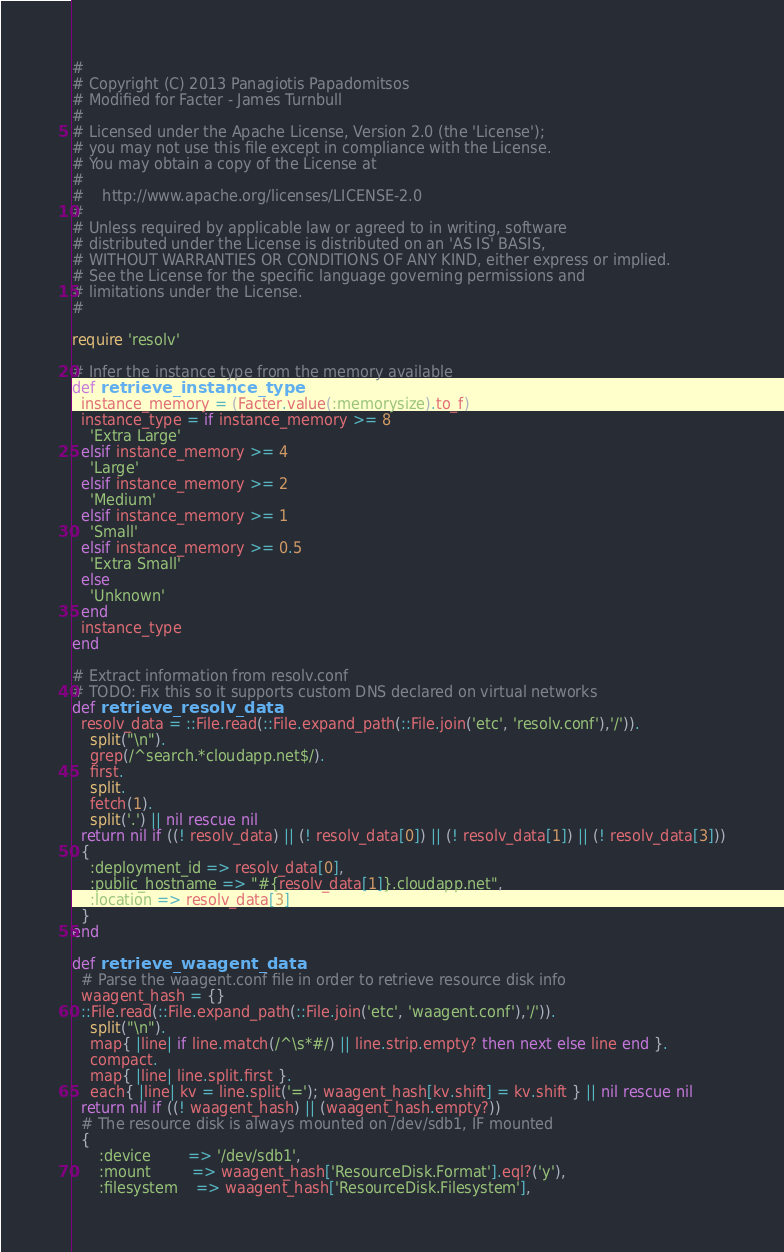<code> <loc_0><loc_0><loc_500><loc_500><_Ruby_>#
# Copyright (C) 2013 Panagiotis Papadomitsos
# Modified for Facter - James Turnbull
#
# Licensed under the Apache License, Version 2.0 (the 'License');
# you may not use this file except in compliance with the License.
# You may obtain a copy of the License at
#
#    http://www.apache.org/licenses/LICENSE-2.0
#
# Unless required by applicable law or agreed to in writing, software
# distributed under the License is distributed on an 'AS IS' BASIS,
# WITHOUT WARRANTIES OR CONDITIONS OF ANY KIND, either express or implied.
# See the License for the specific language governing permissions and
# limitations under the License.
#

require 'resolv'

# Infer the instance type from the memory available
def retrieve_instance_type
  instance_memory = (Facter.value(:memorysize).to_f)
  instance_type = if instance_memory >= 8
    'Extra Large'
  elsif instance_memory >= 4
    'Large'
  elsif instance_memory >= 2
    'Medium'
  elsif instance_memory >= 1
    'Small'
  elsif instance_memory >= 0.5
    'Extra Small'
  else
    'Unknown'
  end
  instance_type
end

# Extract information from resolv.conf
# TODO: Fix this so it supports custom DNS declared on virtual networks
def retrieve_resolv_data
  resolv_data = ::File.read(::File.expand_path(::File.join('etc', 'resolv.conf'),'/')).
    split("\n").
    grep(/^search.*cloudapp.net$/).
    first.
    split.
    fetch(1).
    split('.') || nil rescue nil
  return nil if ((! resolv_data) || (! resolv_data[0]) || (! resolv_data[1]) || (! resolv_data[3]))
  {
    :deployment_id => resolv_data[0],
    :public_hostname => "#{resolv_data[1]}.cloudapp.net",
    :location => resolv_data[3]
  }
end

def retrieve_waagent_data
  # Parse the waagent.conf file in order to retrieve resource disk info
  waagent_hash = {}
  ::File.read(::File.expand_path(::File.join('etc', 'waagent.conf'),'/')).
    split("\n").
    map{ |line| if line.match(/^\s*#/) || line.strip.empty? then next else line end }.
    compact.
    map{ |line| line.split.first }.
    each{ |line| kv = line.split('='); waagent_hash[kv.shift] = kv.shift } || nil rescue nil
  return nil if ((! waagent_hash) || (waagent_hash.empty?))
  # The resource disk is always mounted on /dev/sdb1, IF mounted
  {
      :device        => '/dev/sdb1',
      :mount         => waagent_hash['ResourceDisk.Format'].eql?('y'),
      :filesystem    => waagent_hash['ResourceDisk.Filesystem'],</code> 